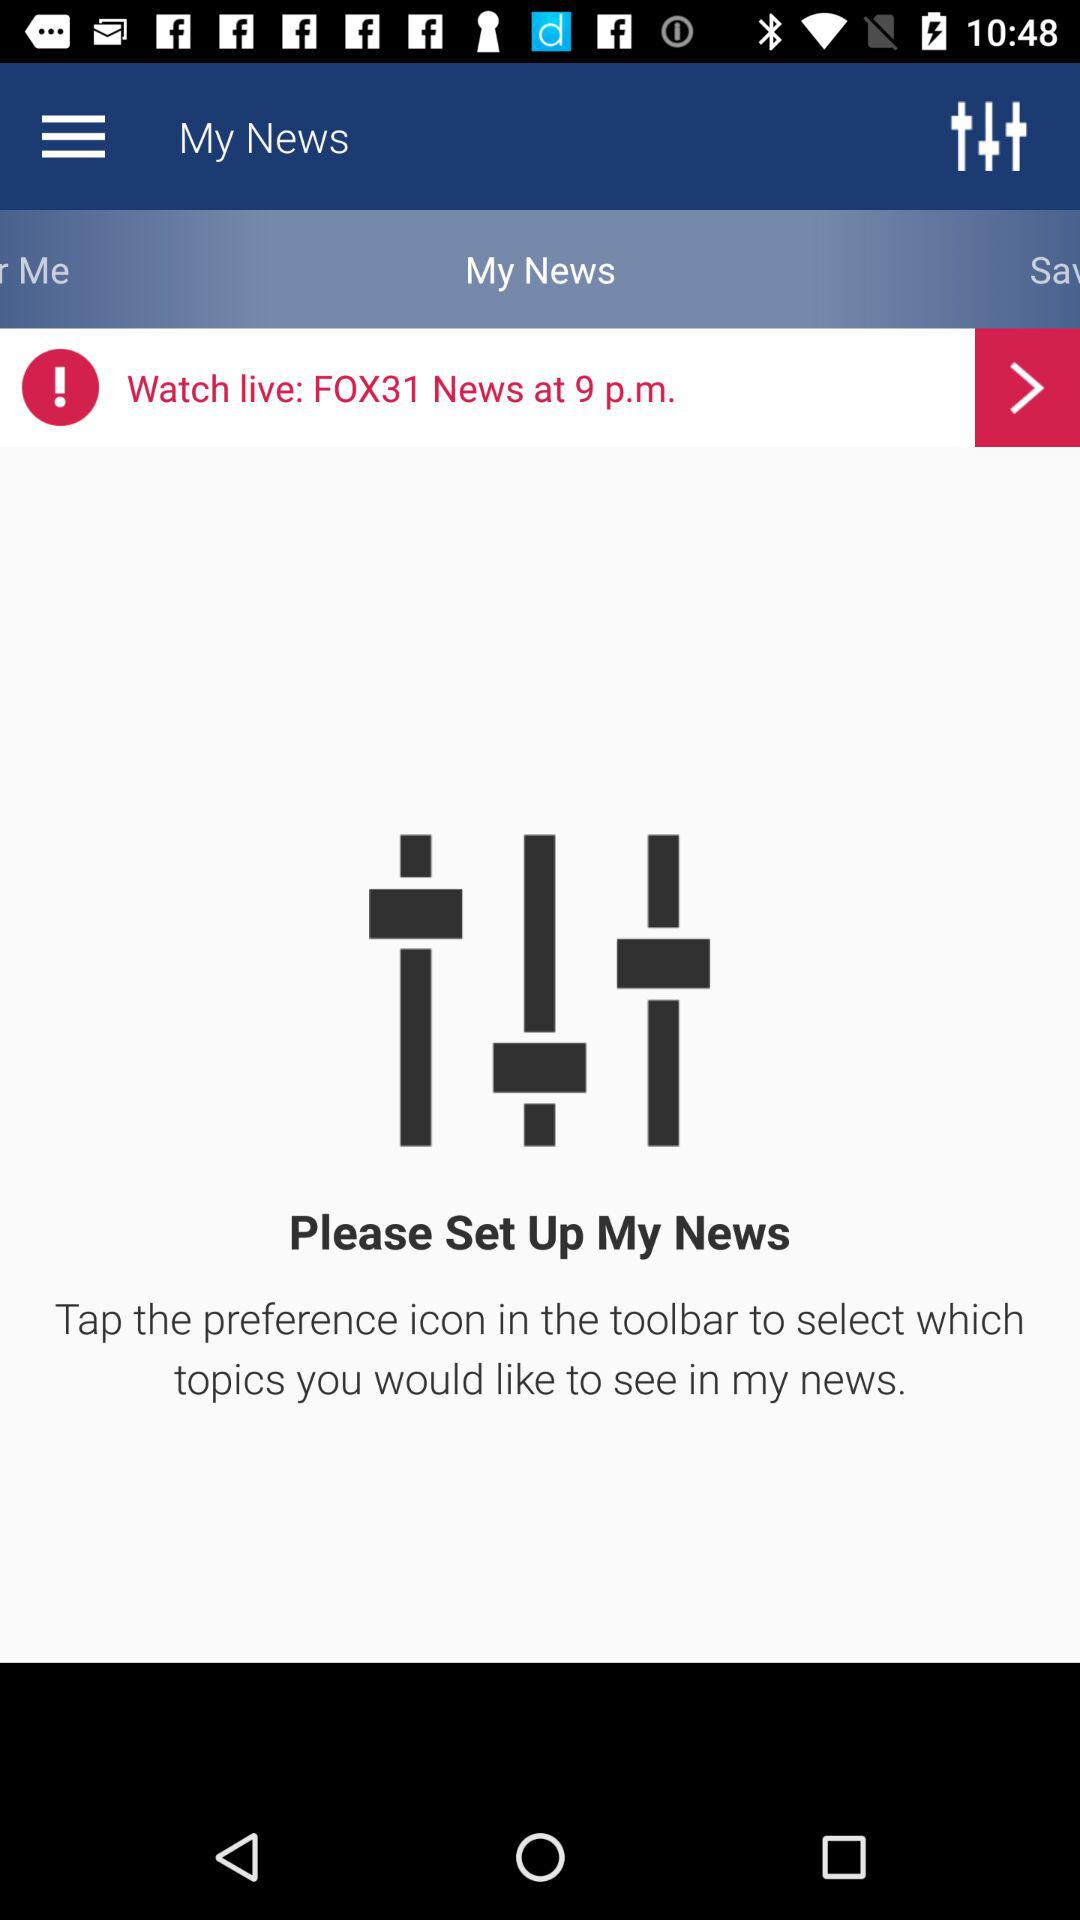What is the name of the news channel? The news channel name is "FOX31 News". 